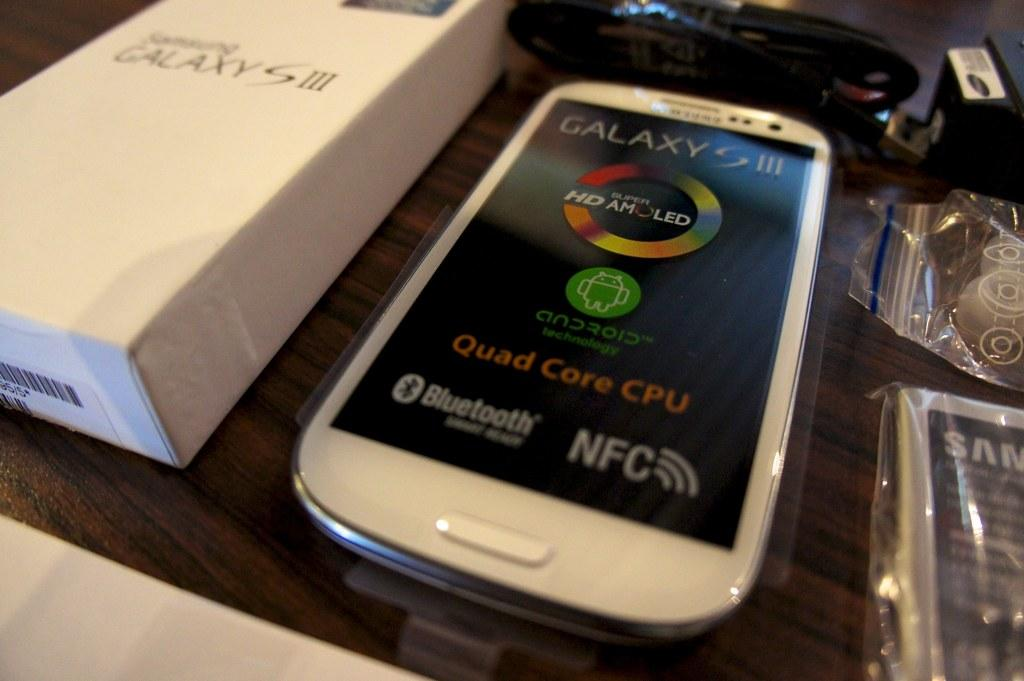<image>
Share a concise interpretation of the image provided. a display of a Galaxy S III cell phone and box 